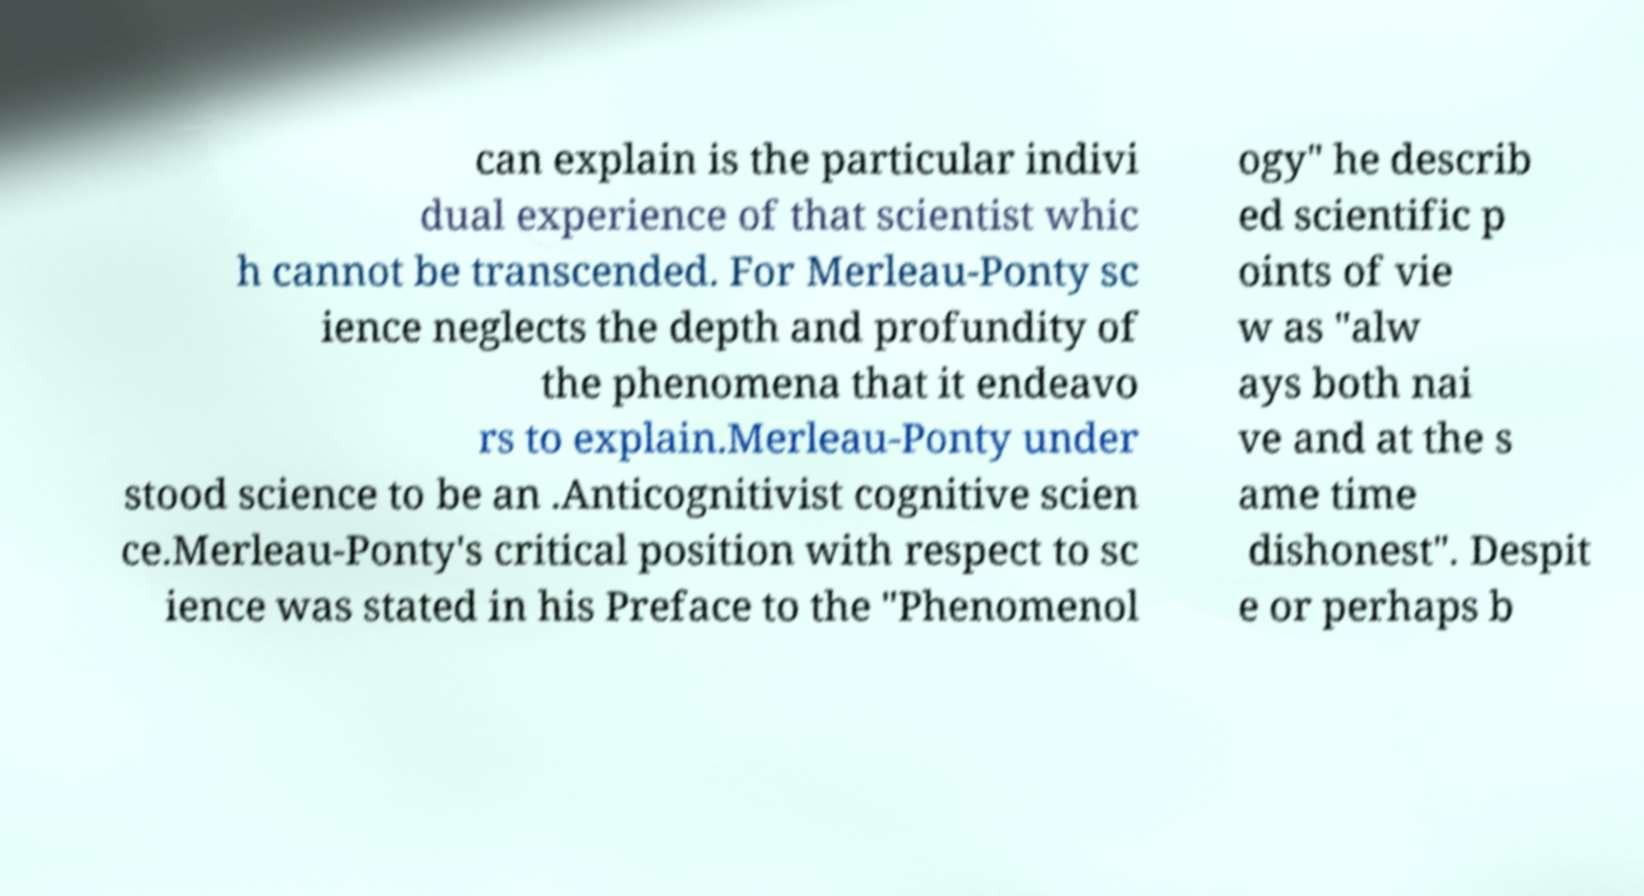For documentation purposes, I need the text within this image transcribed. Could you provide that? can explain is the particular indivi dual experience of that scientist whic h cannot be transcended. For Merleau-Ponty sc ience neglects the depth and profundity of the phenomena that it endeavo rs to explain.Merleau-Ponty under stood science to be an .Anticognitivist cognitive scien ce.Merleau-Ponty's critical position with respect to sc ience was stated in his Preface to the "Phenomenol ogy" he describ ed scientific p oints of vie w as "alw ays both nai ve and at the s ame time dishonest". Despit e or perhaps b 